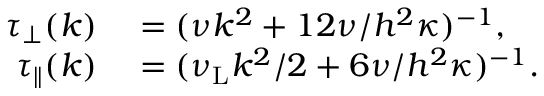<formula> <loc_0><loc_0><loc_500><loc_500>\begin{array} { r l } { \tau _ { \perp } ( k ) } & = ( \nu k ^ { 2 } + 1 2 \nu / h ^ { 2 } \kappa ) ^ { - 1 } , } \\ { \tau _ { \| } ( k ) } & = ( \nu _ { L } k ^ { 2 } / 2 + 6 \nu / h ^ { 2 } \kappa ) ^ { - 1 } . } \end{array}</formula> 